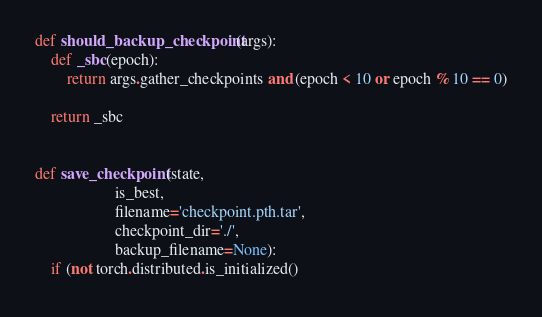<code> <loc_0><loc_0><loc_500><loc_500><_Python_>
def should_backup_checkpoint(args):
    def _sbc(epoch):
        return args.gather_checkpoints and (epoch < 10 or epoch % 10 == 0)

    return _sbc


def save_checkpoint(state,
                    is_best,
                    filename='checkpoint.pth.tar',
                    checkpoint_dir='./',
                    backup_filename=None):
    if (not torch.distributed.is_initialized()</code> 